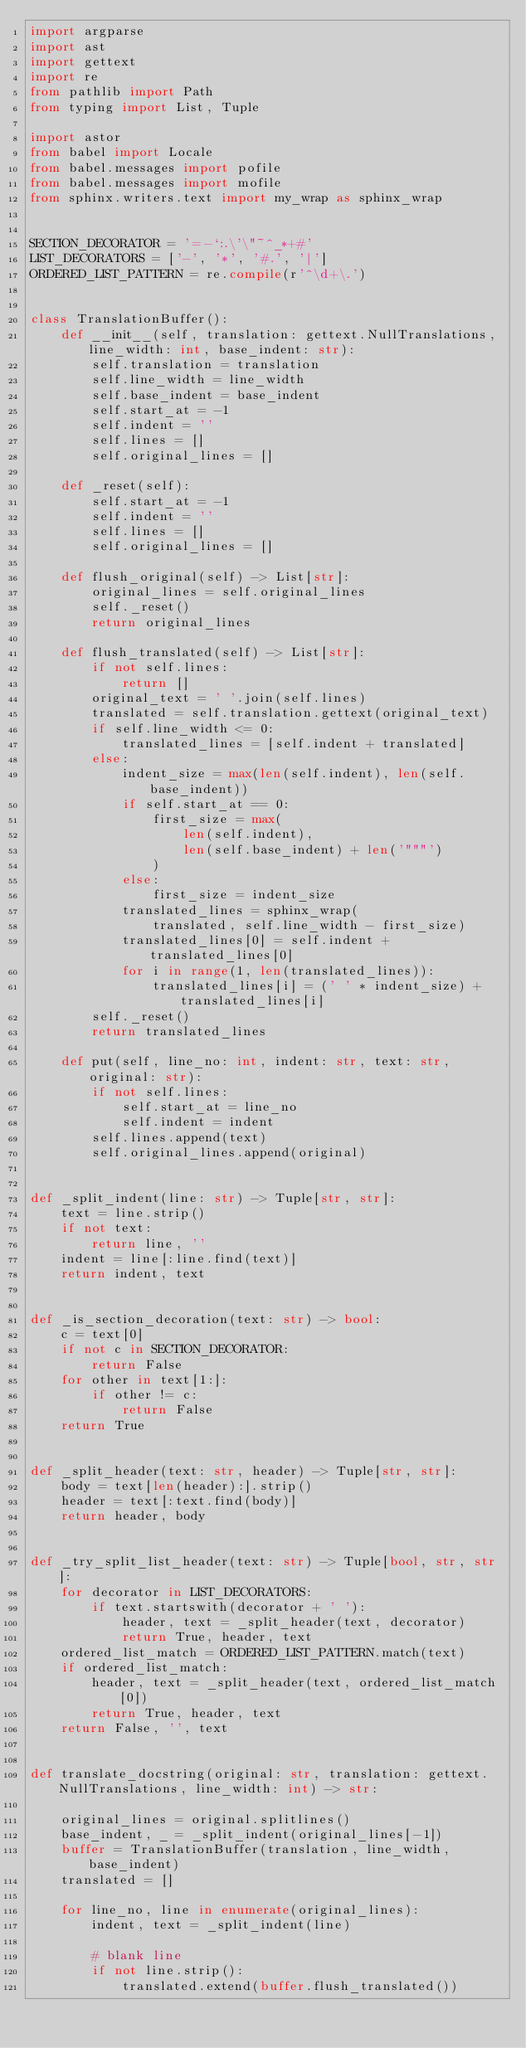Convert code to text. <code><loc_0><loc_0><loc_500><loc_500><_Python_>import argparse
import ast
import gettext
import re
from pathlib import Path
from typing import List, Tuple

import astor
from babel import Locale
from babel.messages import pofile
from babel.messages import mofile
from sphinx.writers.text import my_wrap as sphinx_wrap


SECTION_DECORATOR = '=-`:.\'\"~^_*+#'
LIST_DECORATORS = ['-', '*', '#.', '|']
ORDERED_LIST_PATTERN = re.compile(r'^\d+\.')


class TranslationBuffer():
    def __init__(self, translation: gettext.NullTranslations, line_width: int, base_indent: str):
        self.translation = translation
        self.line_width = line_width
        self.base_indent = base_indent
        self.start_at = -1
        self.indent = ''
        self.lines = []
        self.original_lines = []

    def _reset(self):
        self.start_at = -1
        self.indent = ''
        self.lines = []
        self.original_lines = []

    def flush_original(self) -> List[str]:
        original_lines = self.original_lines
        self._reset()
        return original_lines

    def flush_translated(self) -> List[str]:
        if not self.lines:
            return []
        original_text = ' '.join(self.lines)
        translated = self.translation.gettext(original_text)
        if self.line_width <= 0:
            translated_lines = [self.indent + translated]
        else:
            indent_size = max(len(self.indent), len(self.base_indent))
            if self.start_at == 0:
                first_size = max(
                    len(self.indent),
                    len(self.base_indent) + len('"""')
                )
            else:
                first_size = indent_size
            translated_lines = sphinx_wrap(
                translated, self.line_width - first_size)
            translated_lines[0] = self.indent + translated_lines[0]
            for i in range(1, len(translated_lines)):
                translated_lines[i] = (' ' * indent_size) + translated_lines[i]
        self._reset()
        return translated_lines

    def put(self, line_no: int, indent: str, text: str, original: str):
        if not self.lines:
            self.start_at = line_no
            self.indent = indent
        self.lines.append(text)
        self.original_lines.append(original)


def _split_indent(line: str) -> Tuple[str, str]:
    text = line.strip()
    if not text:
        return line, ''
    indent = line[:line.find(text)]
    return indent, text


def _is_section_decoration(text: str) -> bool:
    c = text[0]
    if not c in SECTION_DECORATOR:
        return False
    for other in text[1:]:
        if other != c:
            return False
    return True


def _split_header(text: str, header) -> Tuple[str, str]:
    body = text[len(header):].strip()
    header = text[:text.find(body)]
    return header, body


def _try_split_list_header(text: str) -> Tuple[bool, str, str]:
    for decorator in LIST_DECORATORS:
        if text.startswith(decorator + ' '):
            header, text = _split_header(text, decorator)
            return True, header, text
    ordered_list_match = ORDERED_LIST_PATTERN.match(text)
    if ordered_list_match:
        header, text = _split_header(text, ordered_list_match[0])
        return True, header, text
    return False, '', text


def translate_docstring(original: str, translation: gettext.NullTranslations, line_width: int) -> str:

    original_lines = original.splitlines()
    base_indent, _ = _split_indent(original_lines[-1])
    buffer = TranslationBuffer(translation, line_width, base_indent)
    translated = []

    for line_no, line in enumerate(original_lines):
        indent, text = _split_indent(line)

        # blank line
        if not line.strip():
            translated.extend(buffer.flush_translated())</code> 